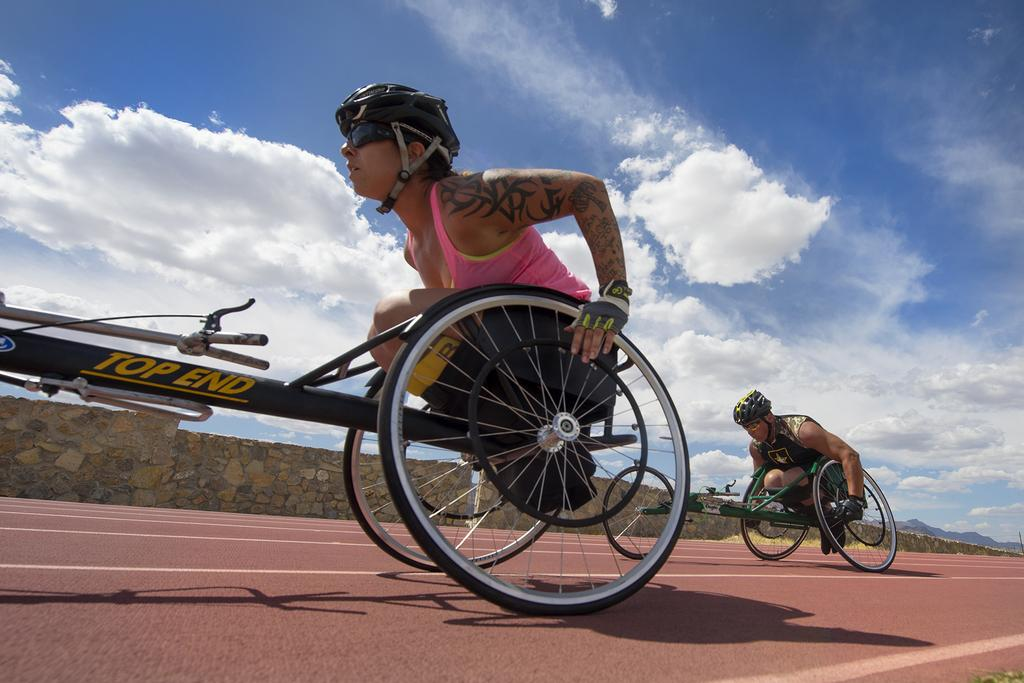How many persons are in the image? There are persons in the image. What protective gear are the persons wearing? The persons are wearing helmets, gloves, and goggles. What are the persons sitting on in the image? The persons are sitting on vehicles. What can be seen in the background of the image? There is a wall in the background of the image. What is visible in the sky in the image? There is sky visible in the image, and clouds are present in the sky. What type of grape is being used as a channel for communication in the image? There is no grape or channel for communication present in the image. What place is depicted in the image? The image does not depict a specific place; it only shows persons wearing protective gear and sitting on vehicles. 